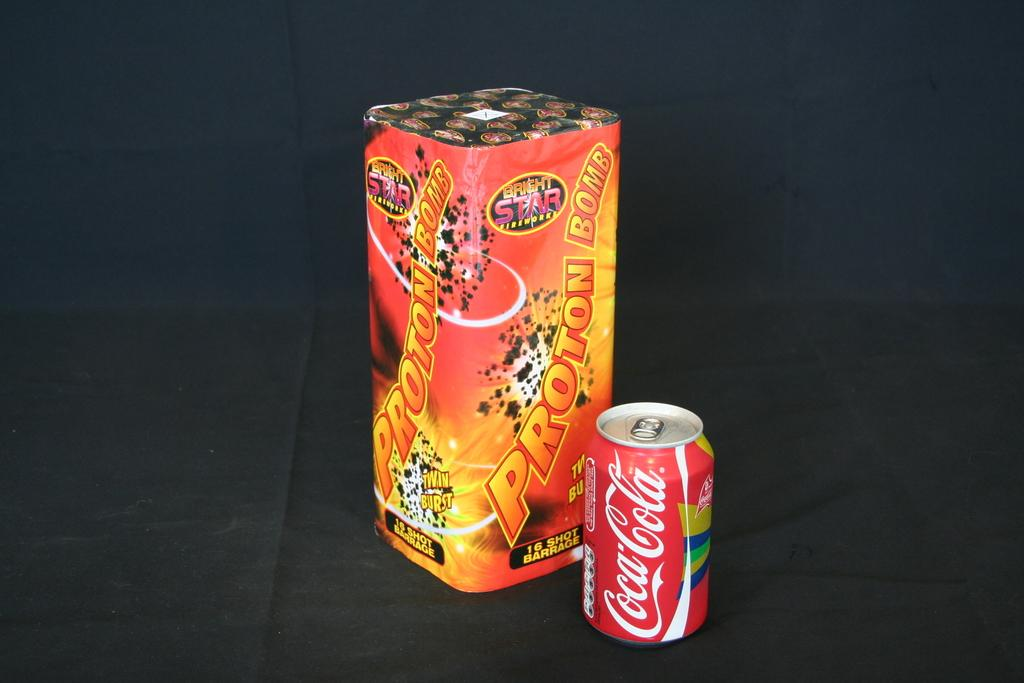What objects are present in the image? There is a box and a tin in the image. What can be found on the surfaces of the box and tin? There is text on both the box and the tin. What is the color of the cloth at the bottom of the image? The cloth at the bottom of the image appears to be black. What type of needle is being used to take a picture of the boundary in the image? There is no needle or camera present in the image, and no boundary is visible. 